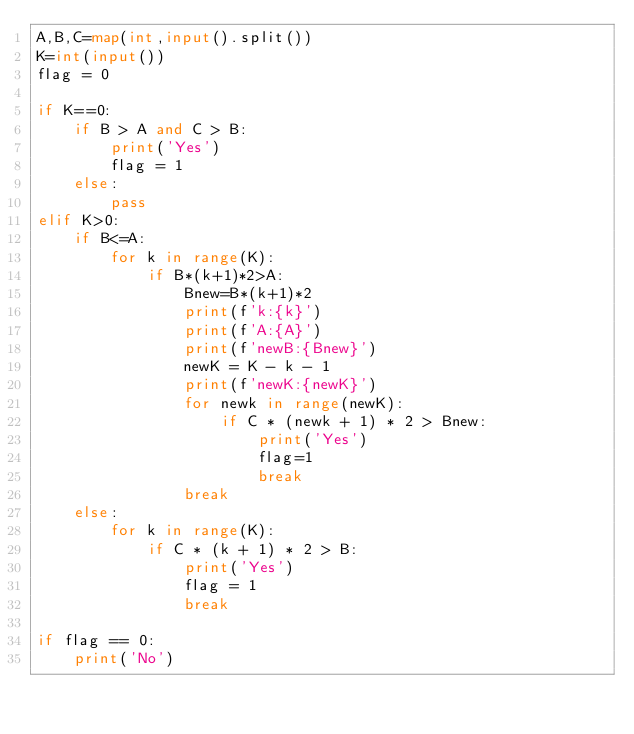<code> <loc_0><loc_0><loc_500><loc_500><_Python_>A,B,C=map(int,input().split())
K=int(input())
flag = 0

if K==0:
    if B > A and C > B:
        print('Yes')
        flag = 1
    else:
        pass
elif K>0:
    if B<=A:
        for k in range(K):
            if B*(k+1)*2>A:
                Bnew=B*(k+1)*2
                print(f'k:{k}')
                print(f'A:{A}')
                print(f'newB:{Bnew}')
                newK = K - k - 1
                print(f'newK:{newK}')
                for newk in range(newK):
                    if C * (newk + 1) * 2 > Bnew:
                        print('Yes')
                        flag=1
                        break
                break
    else:
        for k in range(K):
            if C * (k + 1) * 2 > B:
                print('Yes')
                flag = 1
                break

if flag == 0:
    print('No')</code> 